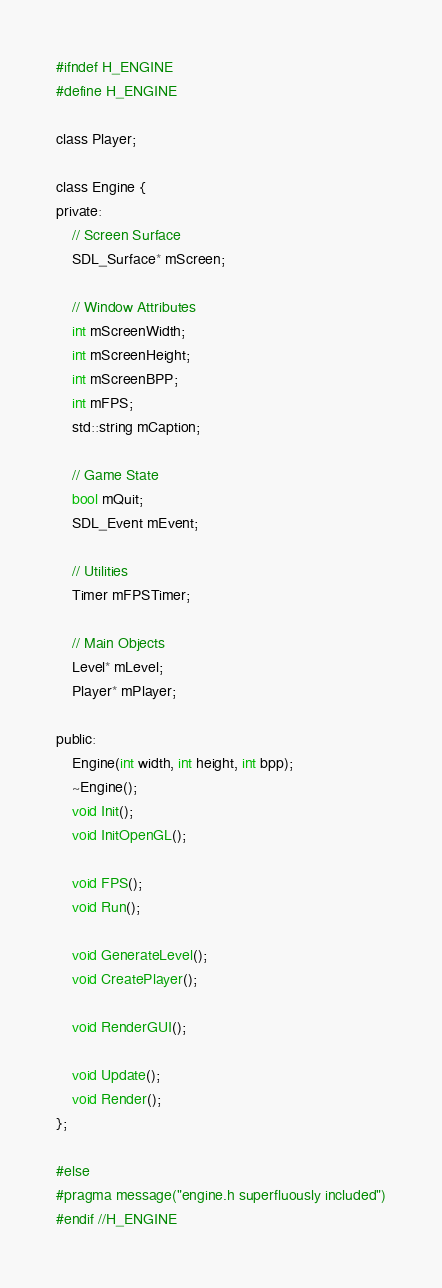Convert code to text. <code><loc_0><loc_0><loc_500><loc_500><_C_>#ifndef H_ENGINE
#define H_ENGINE

class Player;

class Engine {
private:
	// Screen Surface
	SDL_Surface* mScreen;

	// Window Attributes
	int mScreenWidth;
	int mScreenHeight;
	int mScreenBPP;
	int mFPS;
	std::string mCaption;

	// Game State
	bool mQuit;
	SDL_Event mEvent;

	// Utilities
	Timer mFPSTimer;

	// Main Objects
	Level* mLevel;
	Player* mPlayer;

public:
	Engine(int width, int height, int bpp);
	~Engine();
	void Init();
	void InitOpenGL();
	
	void FPS();
	void Run();

	void GenerateLevel();
	void CreatePlayer();

	void RenderGUI();

	void Update();
	void Render();
};

#else
#pragma message("engine.h superfluously included")
#endif //H_ENGINE</code> 